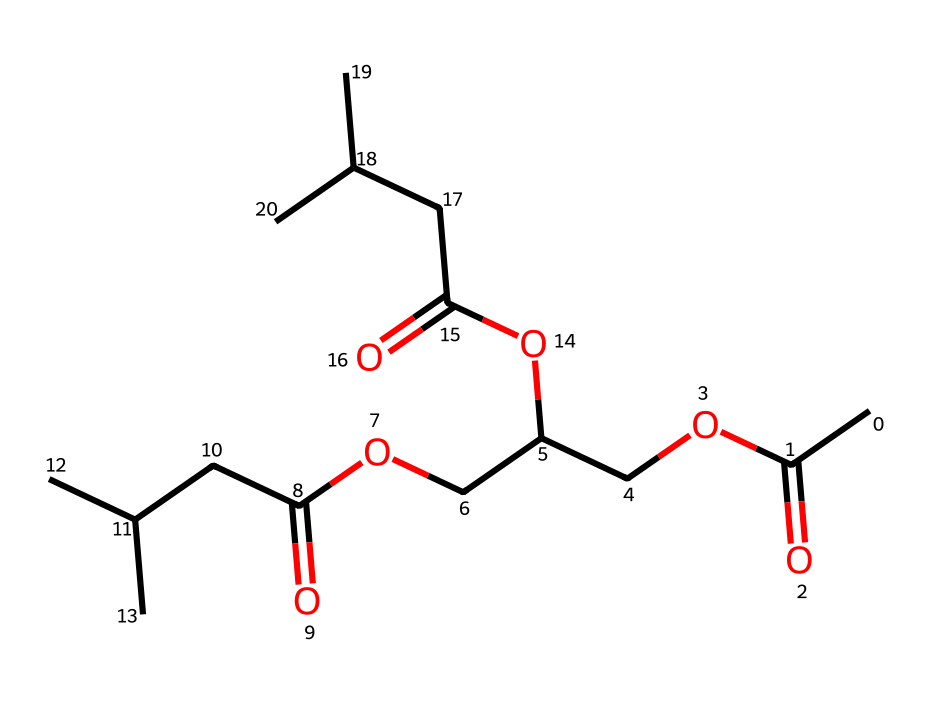What is the main functional group present in this chemical? Analyzing the SMILES representation, we see multiple occurrences of -COO- groups, which are characteristic of esters. Therefore, the main functional group is the ester functional group.
Answer: ester How many carbon atoms are in the structure? By interpreting the SMILES representation, we count the number of carbon atoms present in the structure. Counting each 'C' in the SMILES gives us a total of 18 carbon atoms.
Answer: 18 What type of non-electrolyte is represented by this structure? The chemical structure indicates that it is a non-electrolytic lubricant due to the presence of long carbon chains and ester linkages, common in vegetable-based lubricants.
Answer: vegetable-based lubricant What is the degree of saturation in this molecule? The presence of only single bonds between carbon atoms as inferred from the structure suggests that it is fully saturated without any double or triple bonds, leading to a degree of saturation of 0.
Answer: 0 Are there any cyclic structures in this molecular representation? By reviewing the SMILES representation, there are no indications of any cyclical structures, as all carbon atoms are part of linear or branched chain formations.
Answer: no How many ester groups are present in the structure? Examining the chemical structure, we identify three occurrences of -COO- sequences, indicating that there are three ester groups present in the molecule.
Answer: 3 